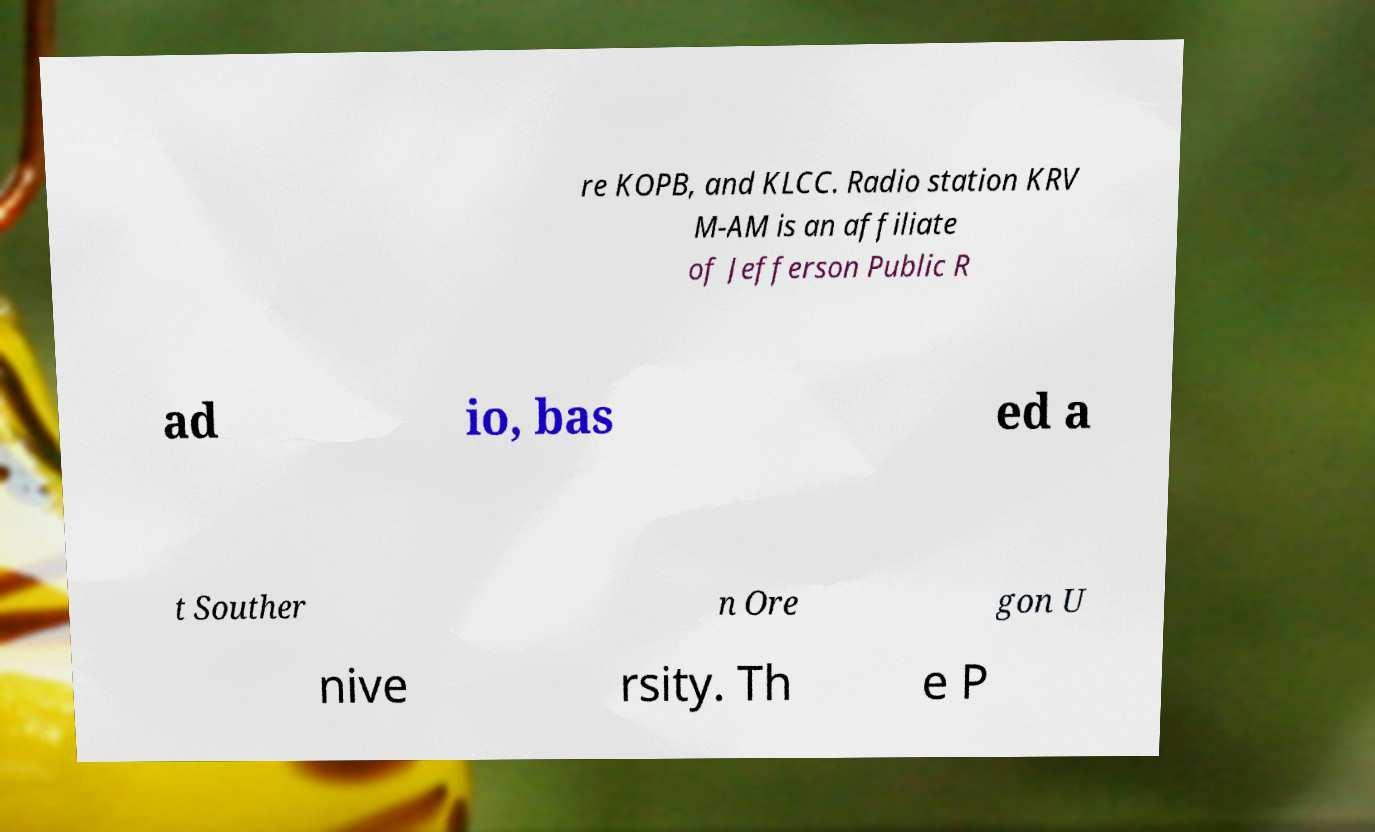Can you accurately transcribe the text from the provided image for me? re KOPB, and KLCC. Radio station KRV M-AM is an affiliate of Jefferson Public R ad io, bas ed a t Souther n Ore gon U nive rsity. Th e P 